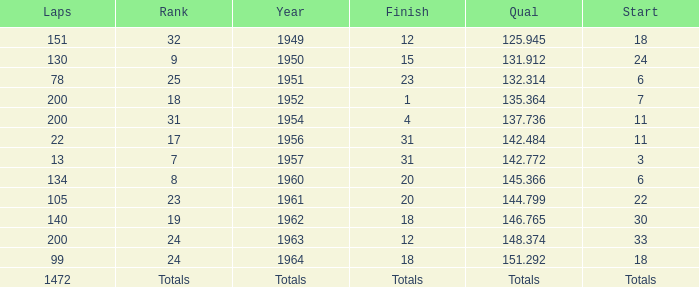Could you parse the entire table as a dict? {'header': ['Laps', 'Rank', 'Year', 'Finish', 'Qual', 'Start'], 'rows': [['151', '32', '1949', '12', '125.945', '18'], ['130', '9', '1950', '15', '131.912', '24'], ['78', '25', '1951', '23', '132.314', '6'], ['200', '18', '1952', '1', '135.364', '7'], ['200', '31', '1954', '4', '137.736', '11'], ['22', '17', '1956', '31', '142.484', '11'], ['13', '7', '1957', '31', '142.772', '3'], ['134', '8', '1960', '20', '145.366', '6'], ['105', '23', '1961', '20', '144.799', '22'], ['140', '19', '1962', '18', '146.765', '30'], ['200', '24', '1963', '12', '148.374', '33'], ['99', '24', '1964', '18', '151.292', '18'], ['1472', 'Totals', 'Totals', 'Totals', 'Totals', 'Totals']]} Name the finish with Laps more than 200 Totals. 